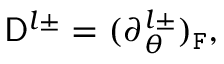<formula> <loc_0><loc_0><loc_500><loc_500>D ^ { l \pm } = ( \partial _ { \theta } ^ { l \pm } ) _ { F } ,</formula> 